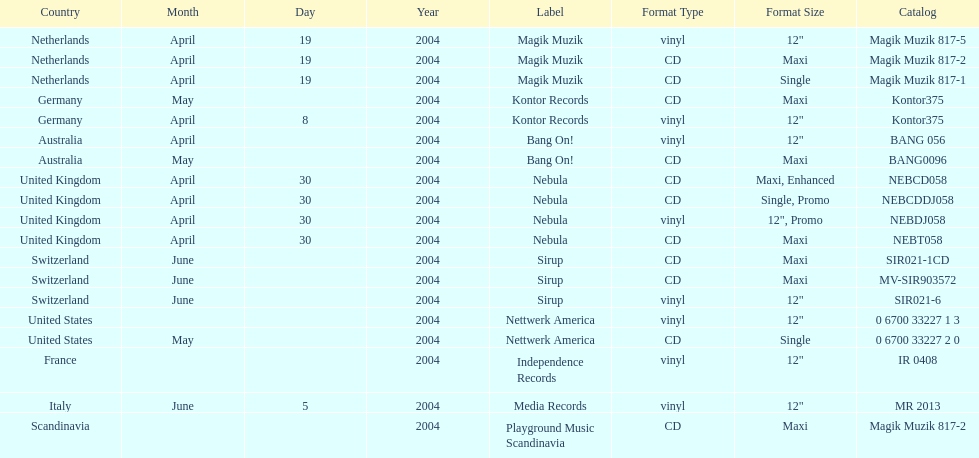What region was on the label sirup? Switzerland. 